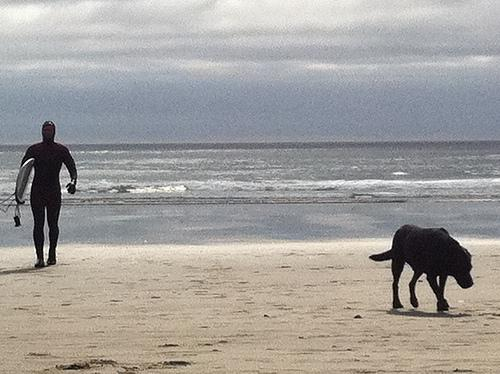Question: what is the man holding?
Choices:
A. Cell.
B. Baby.
C. Book.
D. A surfboard.
Answer with the letter. Answer: D Question: what is the dog doing?
Choices:
A. Pooping.
B. Chasing a squirrel.
C. Smelling the ground.
D. Swimming.
Answer with the letter. Answer: C Question: what is the color of the dog?
Choices:
A. White.
B. Brown.
C. Grey.
D. Black.
Answer with the letter. Answer: D Question: where is the man?
Choices:
A. At the gym.
B. At the beach.
C. At the hotel.
D. At the restaurant.
Answer with the letter. Answer: B Question: who is holding the surfboard?
Choices:
A. The woman.
B. The man.
C. The boy.
D. The girl.
Answer with the letter. Answer: B 